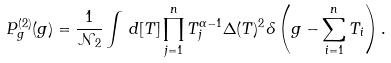Convert formula to latex. <formula><loc_0><loc_0><loc_500><loc_500>P _ { g } ^ { ( 2 ) } ( g ) = \frac { 1 } { \mathcal { N } _ { 2 } } \int \, d [ T ] \prod _ { j = 1 } ^ { n } T _ { j } ^ { \alpha - 1 } \Delta ( T ) ^ { 2 } \delta \left ( g - \sum _ { i = 1 } ^ { n } T _ { i } \right ) .</formula> 